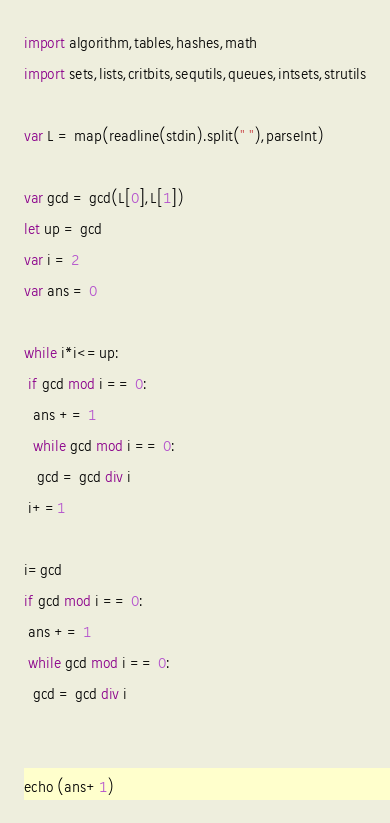<code> <loc_0><loc_0><loc_500><loc_500><_Nim_>import algorithm,tables,hashes,math
import sets,lists,critbits,sequtils,queues,intsets,strutils

var L = map(readline(stdin).split(" "),parseInt)

var gcd = gcd(L[0],L[1])
let up = gcd
var i = 2
var ans = 0

while i*i<=up:
 if gcd mod i == 0:
  ans += 1
  while gcd mod i == 0:
   gcd = gcd div i
 i+=1

i=gcd
if gcd mod i == 0:
 ans += 1
 while gcd mod i == 0:
  gcd = gcd div i


echo (ans+1)</code> 